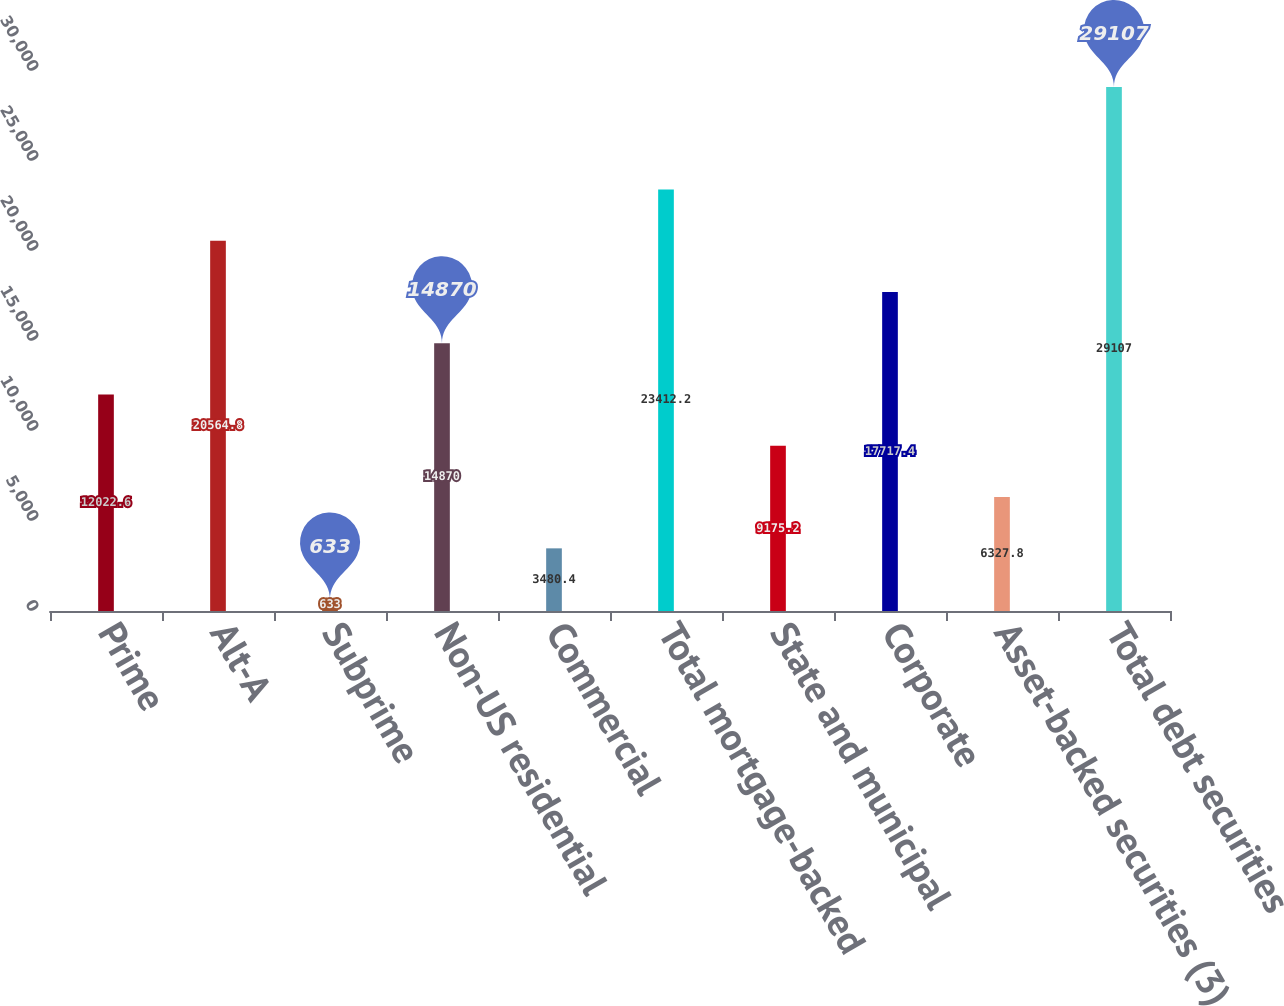Convert chart to OTSL. <chart><loc_0><loc_0><loc_500><loc_500><bar_chart><fcel>Prime<fcel>Alt-A<fcel>Subprime<fcel>Non-US residential<fcel>Commercial<fcel>Total mortgage-backed<fcel>State and municipal<fcel>Corporate<fcel>Asset-backed securities (3)<fcel>Total debt securities<nl><fcel>12022.6<fcel>20564.8<fcel>633<fcel>14870<fcel>3480.4<fcel>23412.2<fcel>9175.2<fcel>17717.4<fcel>6327.8<fcel>29107<nl></chart> 